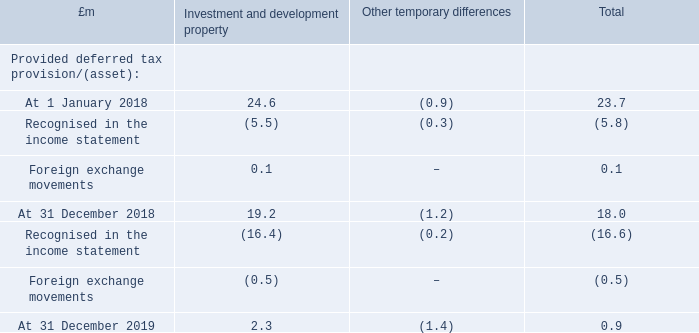Balance sheet
Under IAS 12 Income Taxes, provision is made for the deferred tax assets and liabilities associated with the revaluation of assets and liabilities at the corporate tax rate expected to apply to the Group at the time the temporary differences are expected to reverse. For those UK assets and liabilities benefiting from REIT exemption the relevant tax rate will be 0 per cent (2018: 0 per cent), and for other UK assets and liabilities the relevant rate will be 19 per cent if the temporary difference is expected to be realised before 1 April 2020 and 17 per cent if it is expected to be realised on or after 1 April 2020 (2018: 19 per cent before 1 April 2020, 17 per cent thereafter). For Spanish assets and liabilities the relevant tax rate will be 25 per cent (2018: 25 per cent).
Movements in the provision for deferred tax:
The net deferred tax provision of £0.9 million predominantly arises in respect of the revaluation of development property at intu Costa del Sol, partially offset by associated tax losses.
Why did the net deferred tax provision of £0.9 million arise? In respect of the revaluation of development property at intu costa del sol, partially offset by associated tax losses. What is the relevant tax rate for those UK assets and liabilities benefiting from REIT exemption in 2019? 0 per cent. What is the relevant tax rate for Spanish assets and liabilities? 25 per cent. What is the percentage change in the provided deferred tax provision for investment and development property from 1 January 2018 to 31 December 2019?
Answer scale should be: percent. (2.3-24.6)/24.6
Answer: -90.65. What is the percentage change in the total provided deferred tax provision from 1 January 2018 to 31 December 2019?
Answer scale should be: percent. (0.9-23.7)/0.9
Answer: -25.33. What is the percentage change in the provided deferred tax provision for investment and development property from 31 December 2018 to 31 December 2019?
Answer scale should be: percent. (2.3-19.2)/19.2
Answer: -88.02. 